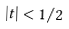<formula> <loc_0><loc_0><loc_500><loc_500>| t | < 1 / 2</formula> 